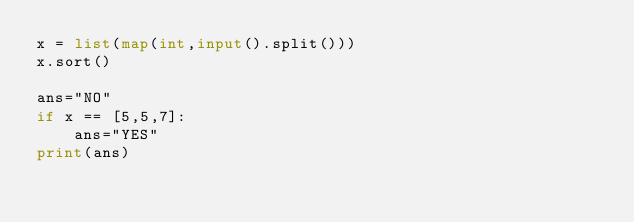Convert code to text. <code><loc_0><loc_0><loc_500><loc_500><_Python_>x = list(map(int,input().split()))
x.sort()

ans="NO"
if x == [5,5,7]:
    ans="YES"
print(ans)
</code> 